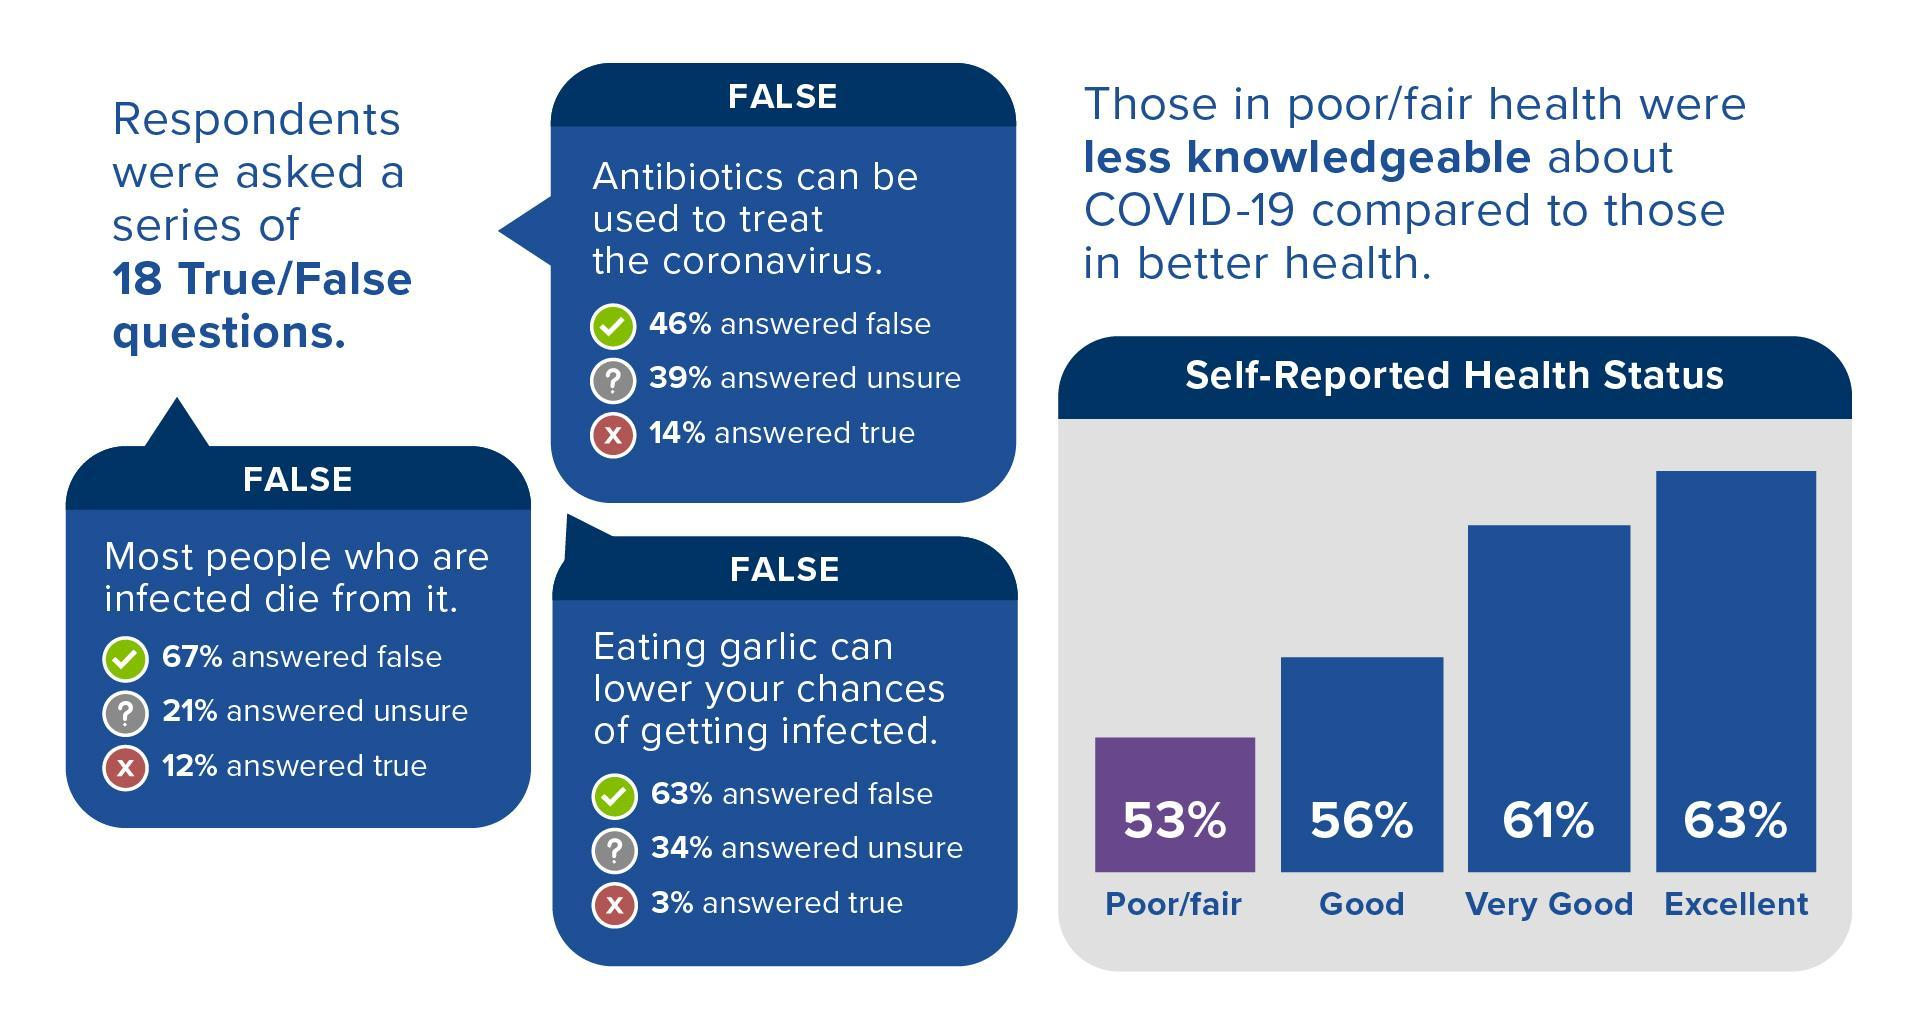What did most respondents answer for self-reported health status?
Answer the question with a short phrase. Excellent Which was the most popular answer for the question on whether antibiotics can be used to treat the coronavirus? False Which was the most popular answer for the question on whether eating garlic can reduce the chances of getting infected?? False What is the second most popular answer for self-reported health status? Very Good 